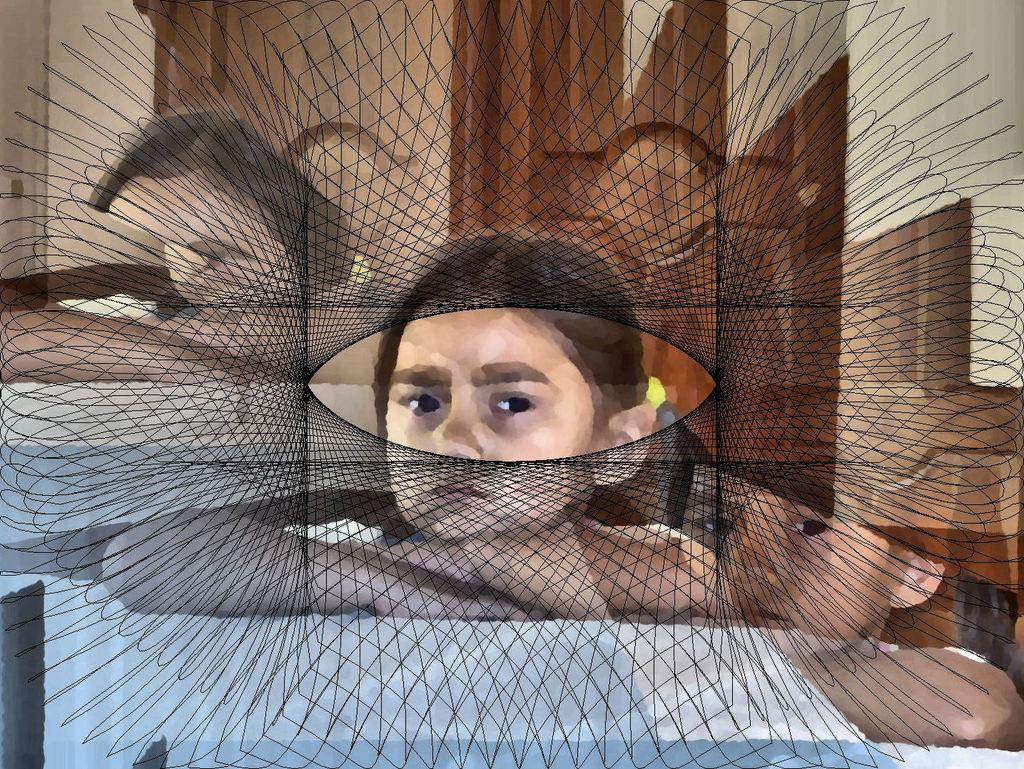What is the main subject of the image? The main subject of the image is the persons in the center. What can be seen in the background of the image? There is a wall and a door in the background of the image. What type of dust can be seen on the persons in the image? There is no dust visible on the persons in the image. Is there a bear present in the image? No, there is no bear present in the image. 